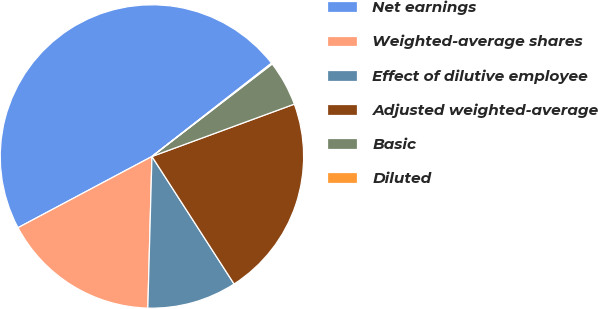Convert chart to OTSL. <chart><loc_0><loc_0><loc_500><loc_500><pie_chart><fcel>Net earnings<fcel>Weighted-average shares<fcel>Effect of dilutive employee<fcel>Adjusted weighted-average<fcel>Basic<fcel>Diluted<nl><fcel>47.23%<fcel>16.79%<fcel>9.54%<fcel>21.5%<fcel>4.83%<fcel>0.11%<nl></chart> 